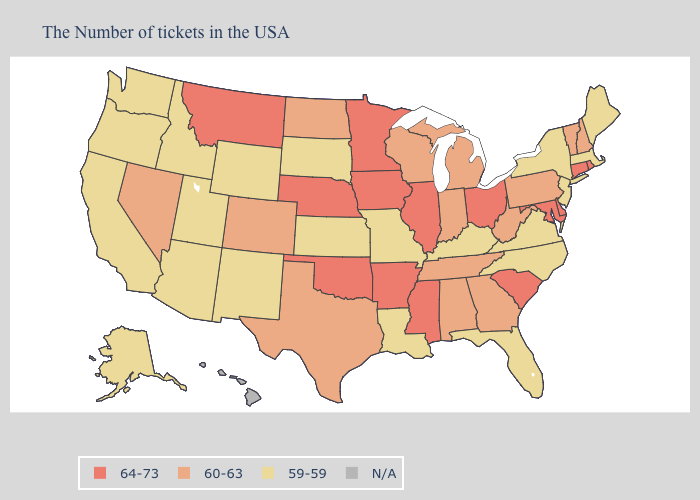What is the highest value in states that border Utah?
Keep it brief. 60-63. Does South Carolina have the lowest value in the South?
Answer briefly. No. What is the highest value in states that border New Hampshire?
Write a very short answer. 60-63. What is the value of New Mexico?
Keep it brief. 59-59. Name the states that have a value in the range N/A?
Keep it brief. Hawaii. What is the value of Tennessee?
Answer briefly. 60-63. Name the states that have a value in the range 59-59?
Quick response, please. Maine, Massachusetts, New York, New Jersey, Virginia, North Carolina, Florida, Kentucky, Louisiana, Missouri, Kansas, South Dakota, Wyoming, New Mexico, Utah, Arizona, Idaho, California, Washington, Oregon, Alaska. What is the highest value in states that border Nevada?
Concise answer only. 59-59. Does Vermont have the lowest value in the Northeast?
Concise answer only. No. Does Maryland have the highest value in the USA?
Concise answer only. Yes. What is the value of Tennessee?
Concise answer only. 60-63. Name the states that have a value in the range N/A?
Keep it brief. Hawaii. What is the value of Florida?
Answer briefly. 59-59. Among the states that border Pennsylvania , which have the highest value?
Quick response, please. Delaware, Maryland, Ohio. 